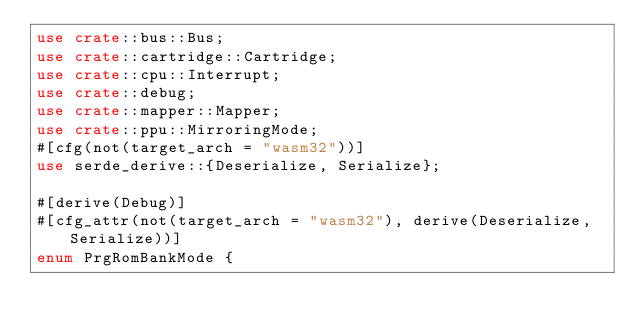<code> <loc_0><loc_0><loc_500><loc_500><_Rust_>use crate::bus::Bus;
use crate::cartridge::Cartridge;
use crate::cpu::Interrupt;
use crate::debug;
use crate::mapper::Mapper;
use crate::ppu::MirroringMode;
#[cfg(not(target_arch = "wasm32"))]
use serde_derive::{Deserialize, Serialize};

#[derive(Debug)]
#[cfg_attr(not(target_arch = "wasm32"), derive(Deserialize, Serialize))]
enum PrgRomBankMode {</code> 